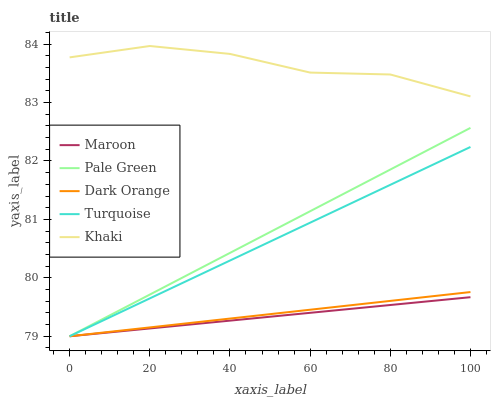Does Maroon have the minimum area under the curve?
Answer yes or no. Yes. Does Khaki have the maximum area under the curve?
Answer yes or no. Yes. Does Turquoise have the minimum area under the curve?
Answer yes or no. No. Does Turquoise have the maximum area under the curve?
Answer yes or no. No. Is Pale Green the smoothest?
Answer yes or no. Yes. Is Khaki the roughest?
Answer yes or no. Yes. Is Turquoise the smoothest?
Answer yes or no. No. Is Turquoise the roughest?
Answer yes or no. No. Does Dark Orange have the lowest value?
Answer yes or no. Yes. Does Khaki have the lowest value?
Answer yes or no. No. Does Khaki have the highest value?
Answer yes or no. Yes. Does Turquoise have the highest value?
Answer yes or no. No. Is Dark Orange less than Khaki?
Answer yes or no. Yes. Is Khaki greater than Dark Orange?
Answer yes or no. Yes. Does Pale Green intersect Dark Orange?
Answer yes or no. Yes. Is Pale Green less than Dark Orange?
Answer yes or no. No. Is Pale Green greater than Dark Orange?
Answer yes or no. No. Does Dark Orange intersect Khaki?
Answer yes or no. No. 